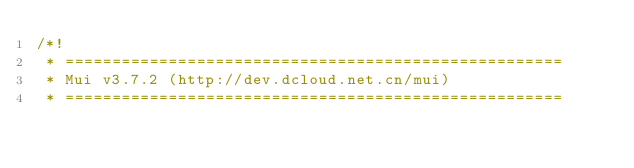Convert code to text. <code><loc_0><loc_0><loc_500><loc_500><_CSS_>/*!
 * =====================================================
 * Mui v3.7.2 (http://dev.dcloud.net.cn/mui)
 * =====================================================</code> 